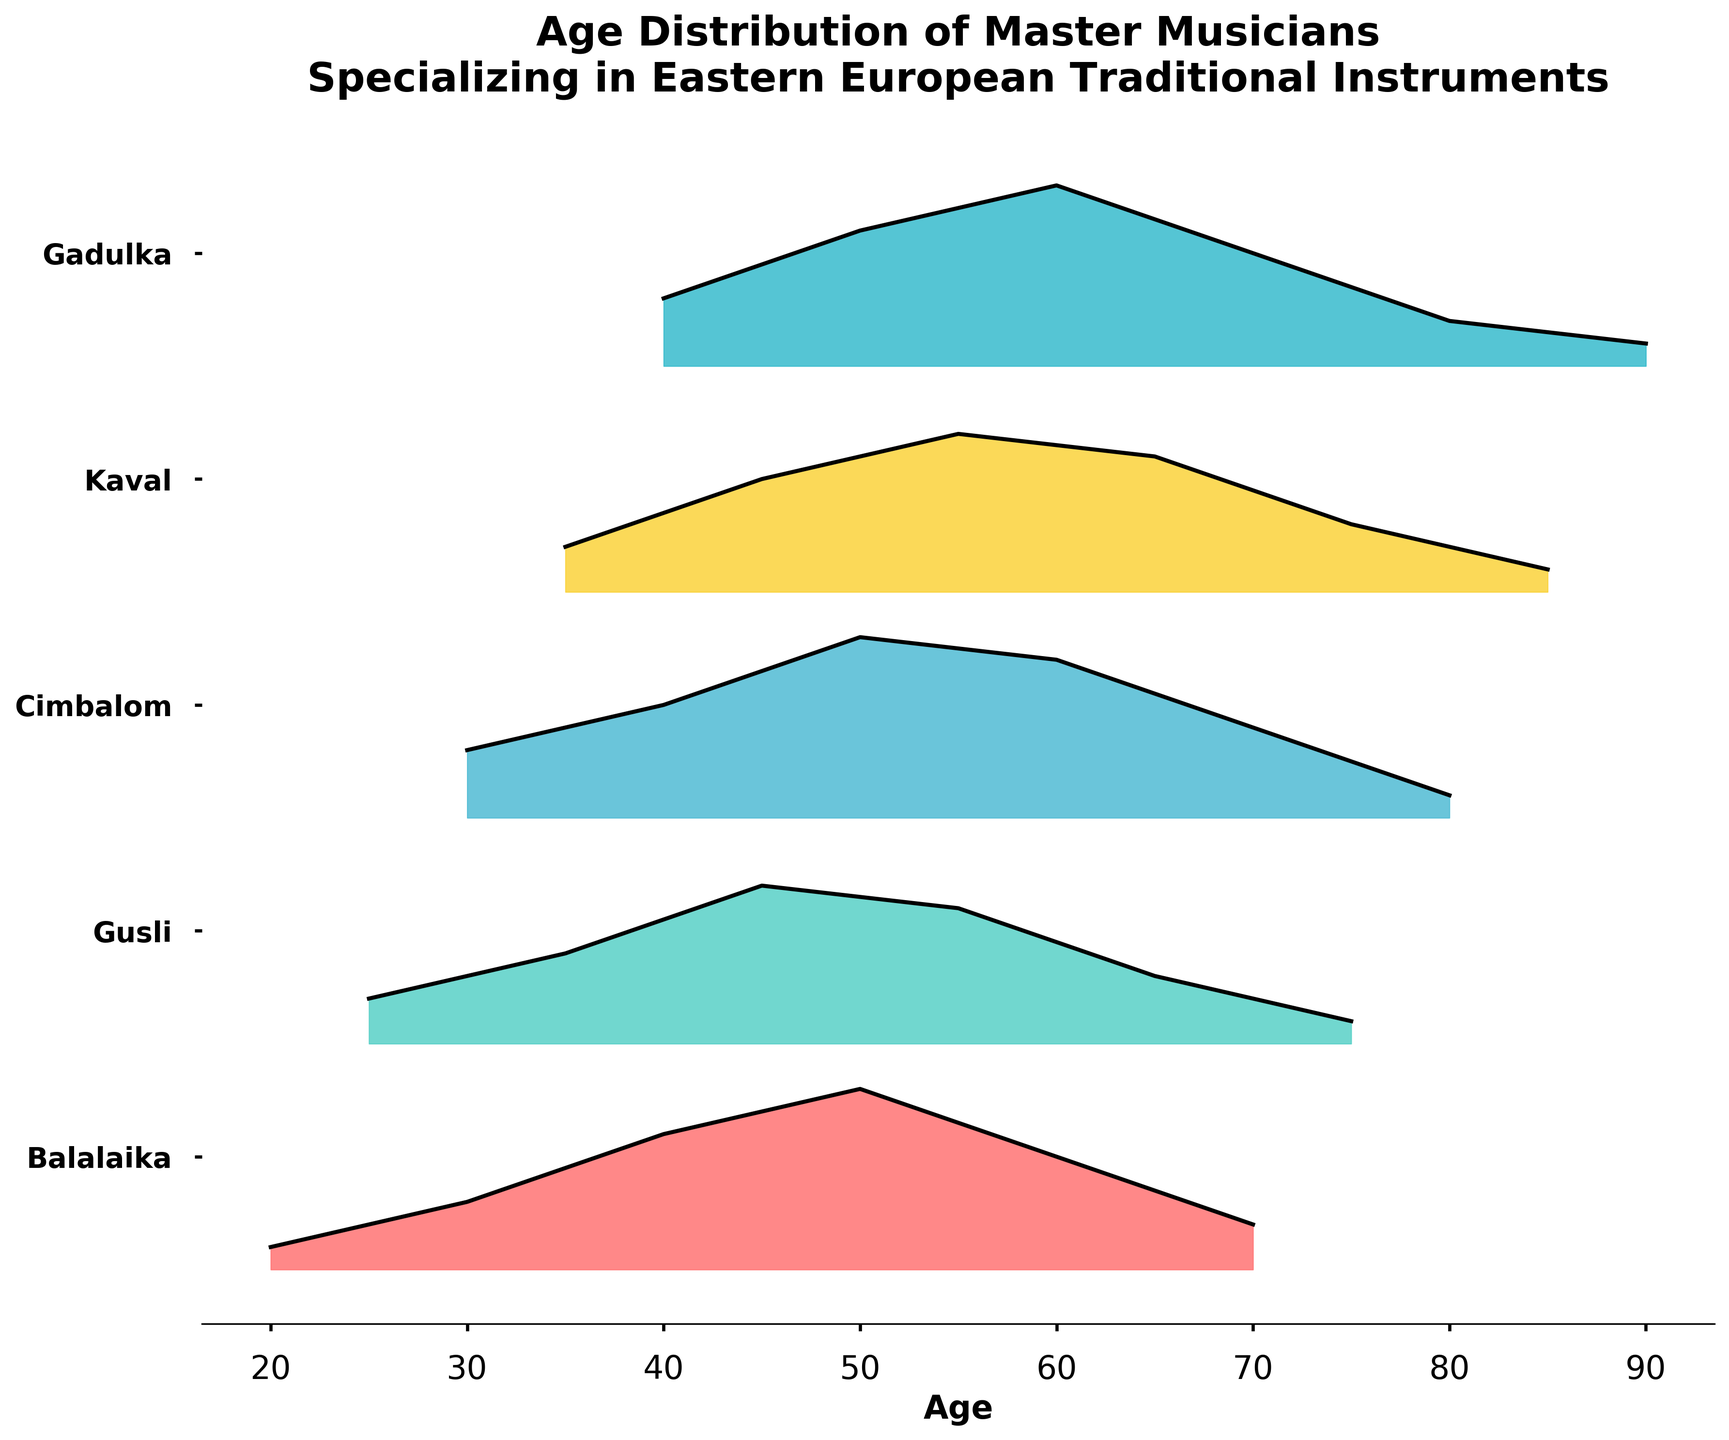What is the title of the figure? The title is prominently displayed at the top of the figure.
Answer: Age Distribution of Master Musicians Specializing in Eastern European Traditional Instruments What instruments are covered in the plot? The instruments are listed on the y-axis labels.
Answer: Balalaika, Gusli, Cimbalom, Kaval, Gadulka At what age is the density of Balalaika players the highest? The highest density for Balalaika players occurs at the peak of the filled area for Balalaika.
Answer: 50 Which instrument has the widest age range of master musicians? The instrument with the widest range has the filled area covering the most age intervals.
Answer: Gadulka How does the peak age for Cimbalom players compare to that of Kaval players? Identify the peak density age for both Cimbalom and Kaval, then compare these ages.
Answer: Cimbalom: 50; Kaval: 55 What is the general trend of the density curves for Gusli and Gadulka players as age increases? Observe how the density curves rise and fall with increasing age for both instruments.
Answer: Both increase to a peak and then slowly decrease Which instruments have a peak density for players aged 50? Identify which instruments have a twin peak curve at age 50.
Answer: Balalaika, Cimbalom, Gadulka What is the smallest density value represented on the plot? The smallest density is represented where the filled area is thinnest across all instruments.
Answer: 0.01 How does the age distribution of Kaval players differ from that of Balalaika players? Compare the shapes and peak positions of the density curves for both instruments.
Answer: Kaval players peak at 55 and 65, while Balalaika peaks at 50 Which instrument has the most dispersed age distribution? The most dispersed age distribution is visible as the broadest and most evenly spread filled area.
Answer: Gadulka 